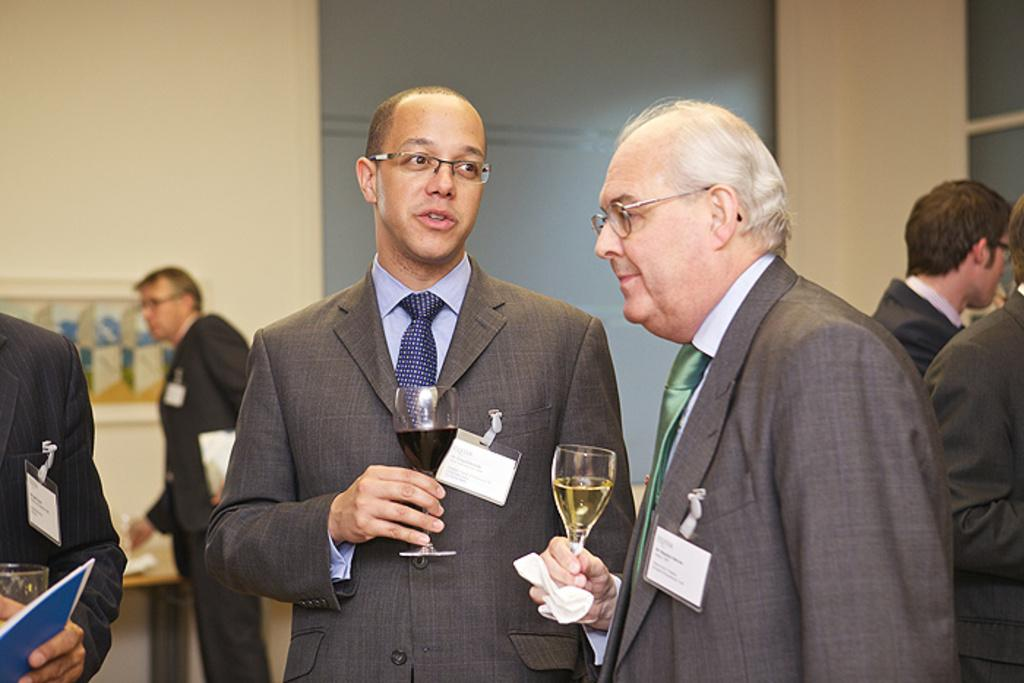What can be seen in the foreground of the picture? There are men in the foreground of the picture. What are some of the men doing in the picture? Some of the men are holding glasses. Where are the people located on the right side of the image? There are people on the right side of the image. What is visible in the background of the image? There is a person, a table, a frame, and a wall in the background of the image. What type of rub can be seen on the cave wall in the image? There is no cave or rub present in the image. How many mice are visible on the table in the image? There are no mice present in the image; the table is empty. 